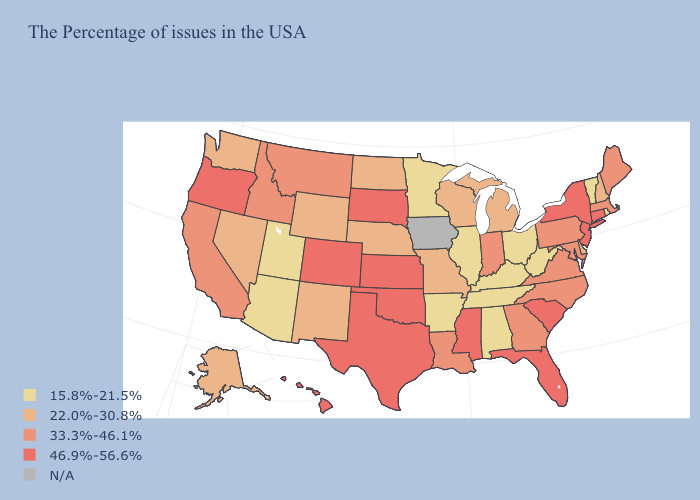Name the states that have a value in the range N/A?
Be succinct. Iowa. Is the legend a continuous bar?
Give a very brief answer. No. Does Florida have the lowest value in the USA?
Keep it brief. No. Does Oklahoma have the highest value in the USA?
Give a very brief answer. Yes. How many symbols are there in the legend?
Short answer required. 5. How many symbols are there in the legend?
Concise answer only. 5. Does Michigan have the lowest value in the MidWest?
Write a very short answer. No. What is the highest value in states that border Florida?
Short answer required. 33.3%-46.1%. Is the legend a continuous bar?
Quick response, please. No. Name the states that have a value in the range N/A?
Give a very brief answer. Iowa. What is the highest value in the MidWest ?
Quick response, please. 46.9%-56.6%. What is the highest value in the West ?
Write a very short answer. 46.9%-56.6%. Does Arkansas have the highest value in the South?
Be succinct. No. What is the highest value in the USA?
Write a very short answer. 46.9%-56.6%. 